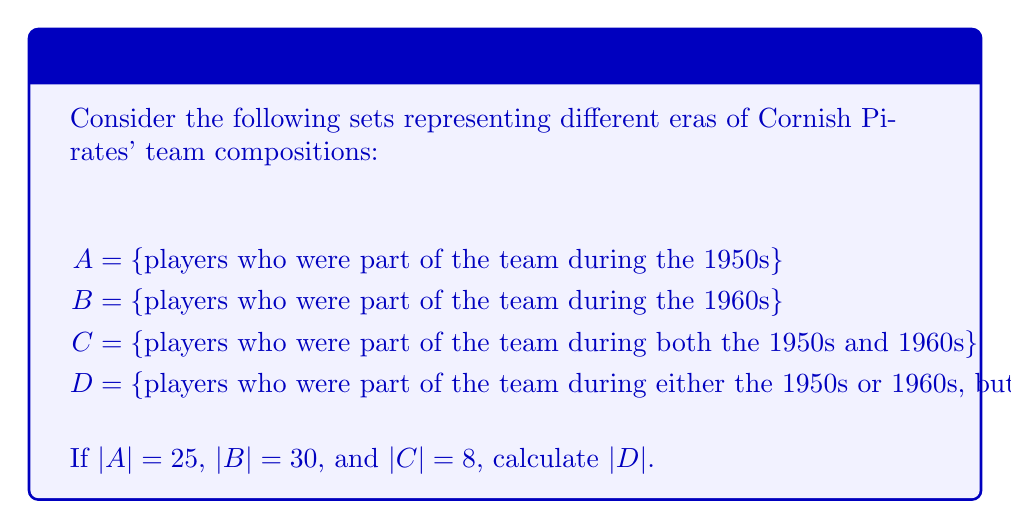Provide a solution to this math problem. To solve this problem, we'll use set theory concepts and the given information:

1) First, let's recall the formula for the number of elements in the union of two sets:
   $$ |A \cup B| = |A| + |B| - |A \cap B| $$

2) In this case, C represents the intersection of A and B:
   $$ C = A \cap B $$
   So, |C| = |A ∩ B| = 8

3) D represents the symmetric difference of A and B, which can be expressed as:
   $$ D = (A \cup B) \setminus (A \cap B) $$

4) The number of elements in D can be calculated as:
   $$ |D| = |A \cup B| - |A \cap B| $$

5) We can now use the formula from step 1 to find |A ∪ B|:
   $$ |A \cup B| = |A| + |B| - |A \cap B| $$
   $$ |A \cup B| = 25 + 30 - 8 = 47 $$

6) Finally, we can calculate |D|:
   $$ |D| = |A \cup B| - |A \cap B| $$
   $$ |D| = 47 - 8 = 39 $$

Therefore, there were 39 players who were part of the Cornish Pirates team during either the 1950s or 1960s, but not both.
Answer: |D| = 39 